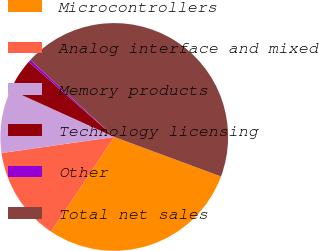Convert chart. <chart><loc_0><loc_0><loc_500><loc_500><pie_chart><fcel>Microcontrollers<fcel>Analog interface and mixed<fcel>Memory products<fcel>Technology licensing<fcel>Other<fcel>Total net sales<nl><fcel>28.7%<fcel>13.39%<fcel>9.04%<fcel>4.7%<fcel>0.35%<fcel>43.82%<nl></chart> 